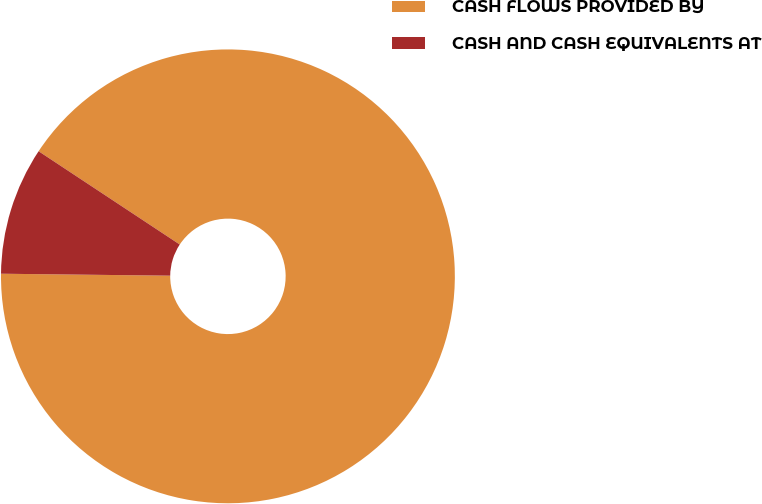<chart> <loc_0><loc_0><loc_500><loc_500><pie_chart><fcel>CASH FLOWS PROVIDED BY<fcel>CASH AND CASH EQUIVALENTS AT<nl><fcel>90.89%<fcel>9.11%<nl></chart> 